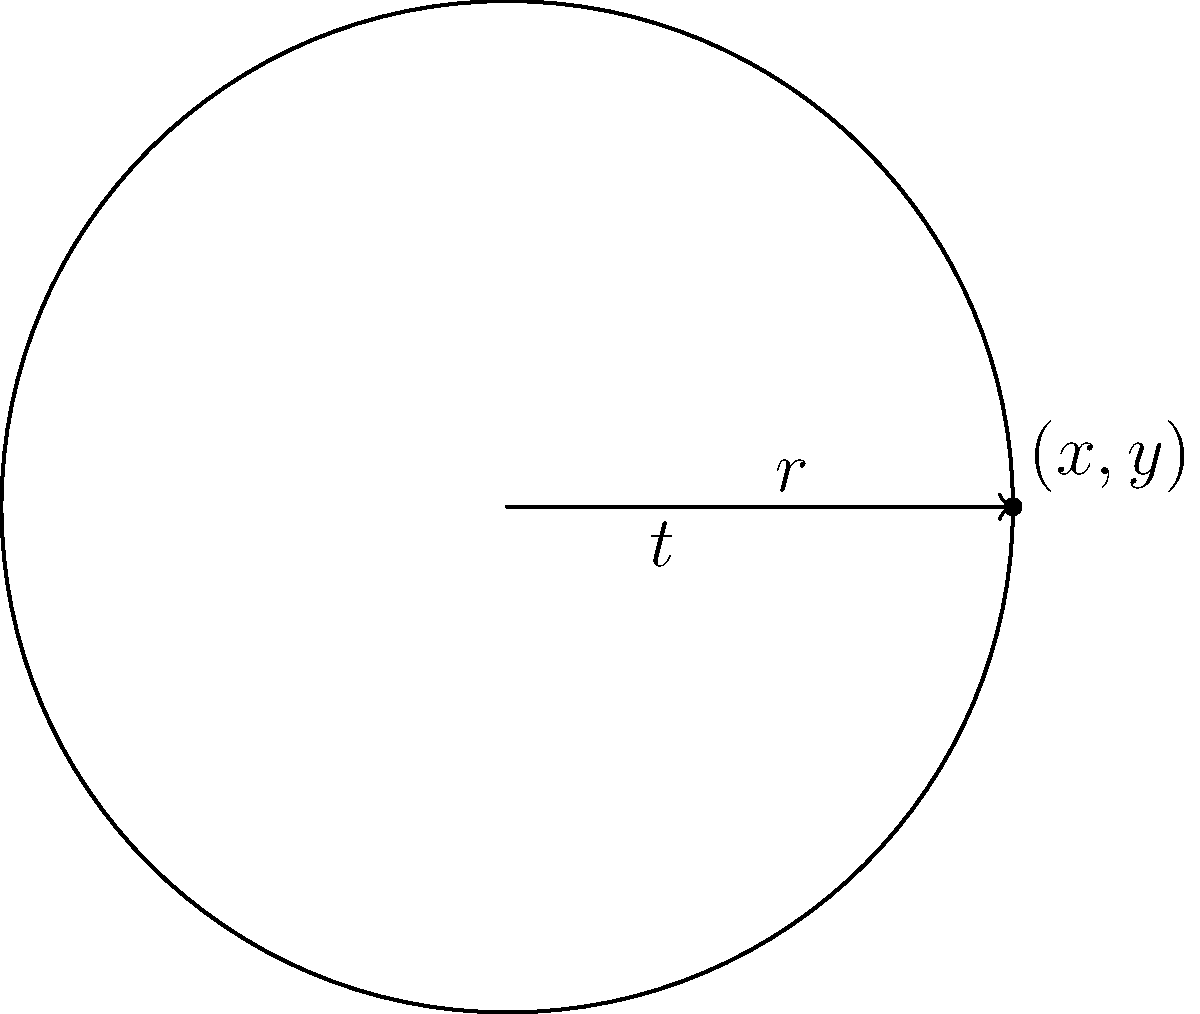You're designing a rotating light effect for a dynamic cosplay scene. The light source moves in a circular path with a radius of 2 meters. If the light completes one full rotation every 6 seconds, what are the x and y coordinates of the light source after 2.5 seconds? Express your answer in terms of $\pi$. Let's approach this step-by-step:

1) First, we need to determine the angular velocity $\omega$:
   One full rotation = $2\pi$ radians
   Time for one rotation = 6 seconds
   $\omega = \frac{2\pi}{6} = \frac{\pi}{3}$ radians/second

2) Now, we can calculate the angle $t$ after 2.5 seconds:
   $t = \omega \times \text{time} = \frac{\pi}{3} \times 2.5 = \frac{5\pi}{6}$ radians

3) We know that for a circle with radius $r$:
   $x = r \cos(t)$
   $y = r \sin(t)$

4) Given $r = 2$ and $t = \frac{5\pi}{6}$, we can calculate:
   $x = 2 \cos(\frac{5\pi}{6}) = 2 \times (-\frac{\sqrt{3}}{2}) = -\sqrt{3}$
   $y = 2 \sin(\frac{5\pi}{6}) = 2 \times \frac{1}{2} = 1$

Therefore, after 2.5 seconds, the light source will be at the coordinates $(-\sqrt{3}, 1)$.
Answer: $(-\sqrt{3}, 1)$ 